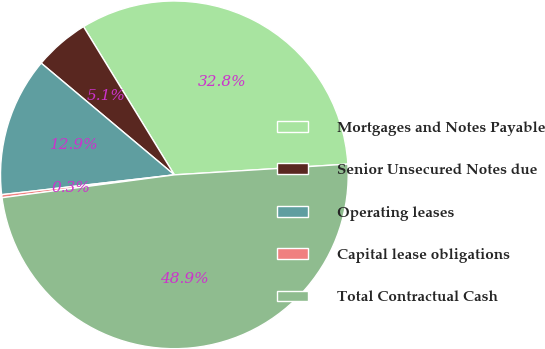<chart> <loc_0><loc_0><loc_500><loc_500><pie_chart><fcel>Mortgages and Notes Payable<fcel>Senior Unsecured Notes due<fcel>Operating leases<fcel>Capital lease obligations<fcel>Total Contractual Cash<nl><fcel>32.77%<fcel>5.14%<fcel>12.93%<fcel>0.28%<fcel>48.89%<nl></chart> 